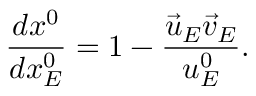<formula> <loc_0><loc_0><loc_500><loc_500>\frac { d x ^ { 0 } } { d x _ { E } ^ { 0 } } = 1 - \frac { \vec { u } _ { E } \vec { v } _ { E } } { u _ { E } ^ { 0 } } .</formula> 